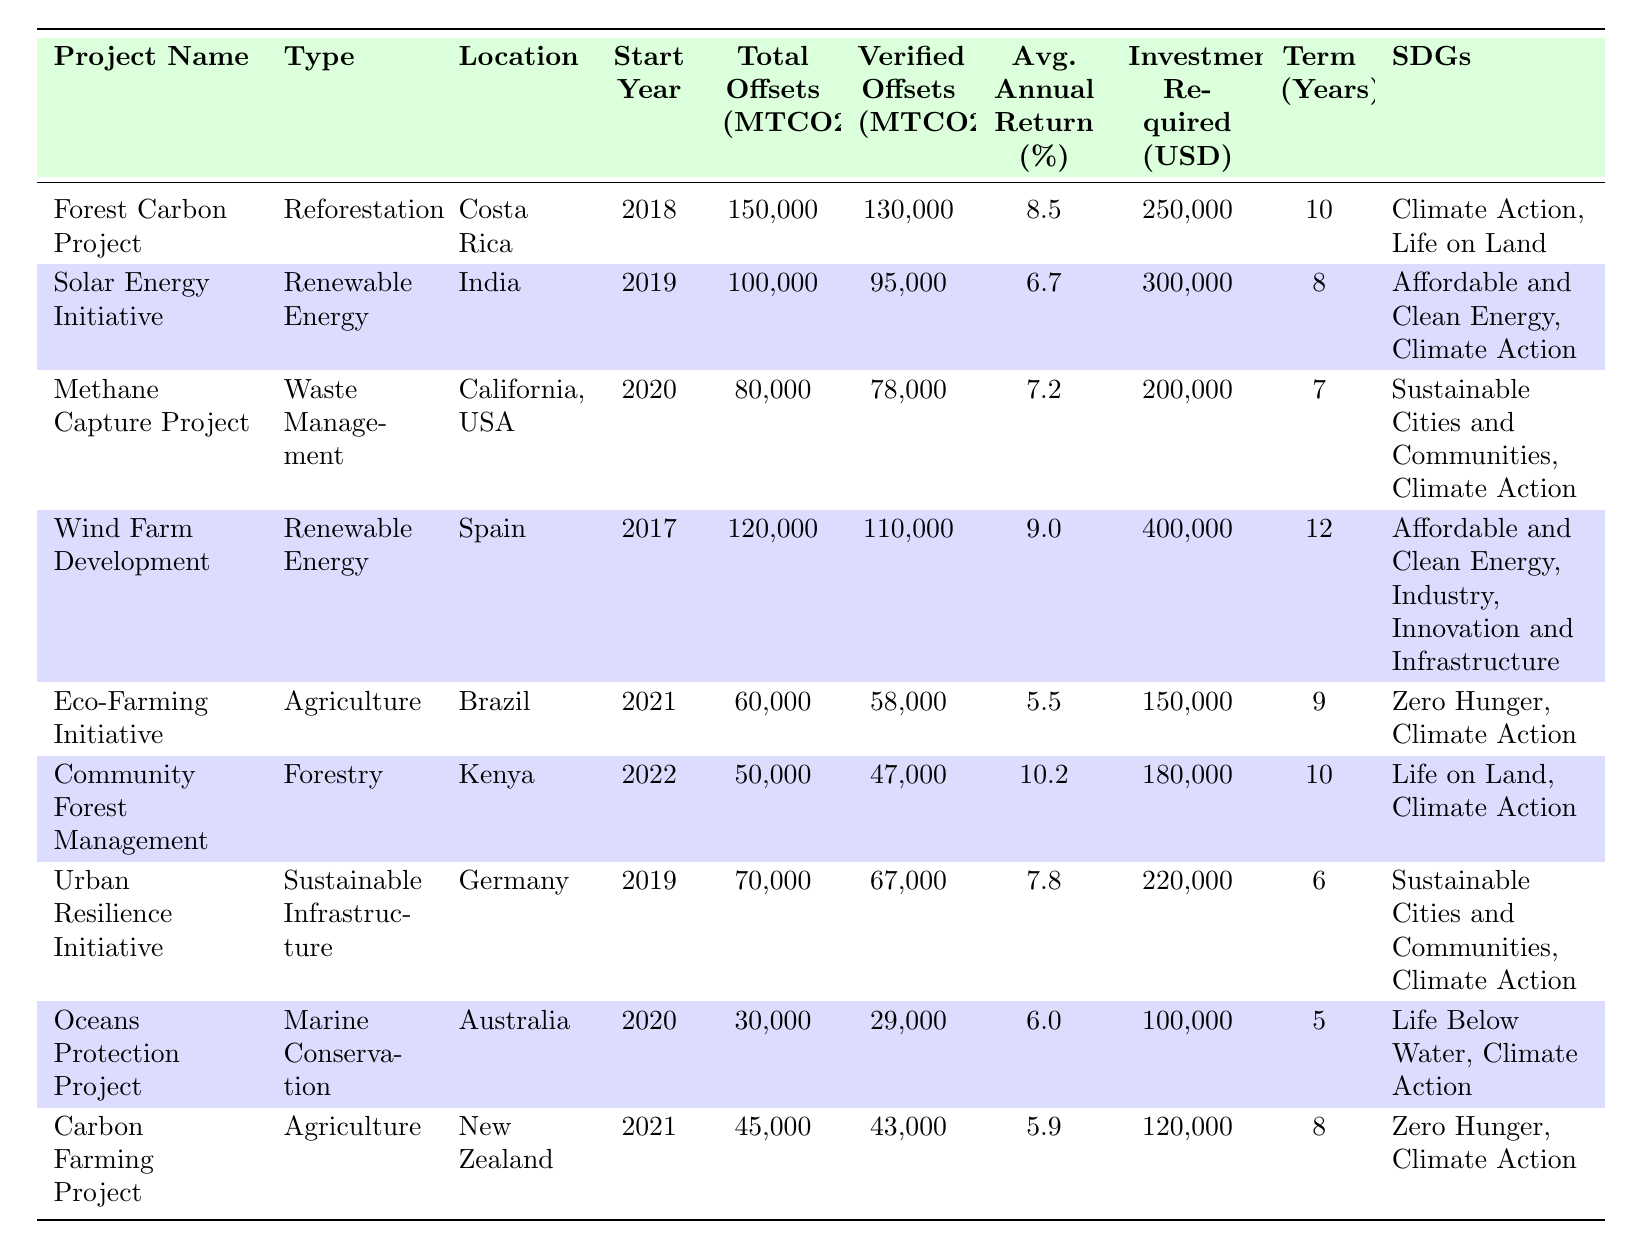What project has the highest average annual return percentage? The table shows the average annual return percentage for each project. The highest value is 10.2%, associated with the Community Forest Management project in Kenya.
Answer: 10.2% How many projects are categorized as Renewable Energy? The table lists the projects under the "Type" column. There are two projects under Renewable Energy: the Solar Energy Initiative (India) and Wind Farm Development (Spain).
Answer: 2 What is the total carbon offset (MTCO2e) for all projects listed? To find the total carbon offset, add the total offsets for each project: 150,000 + 100,000 + 80,000 + 120,000 + 60,000 + 50,000 + 70,000 + 30,000 + 45,000 = 705,000.
Answer: 705,000 MTCO2e Which project has the lowest investment required? By inspecting the "Investment Required" column, the project with the lowest investment of USD 100,000 is the Oceans Protection Project in Australia.
Answer: 100,000 USD Is there a project that meets the Sustainable Development Goal of "Zero Hunger"? The Eco-Farming Initiative (Brazil) and Carbon Farming Project (New Zealand) both aim to achieve the Sustainable Development Goal of "Zero Hunger".
Answer: Yes What is the average investment required for projects in Africa? The projects in Africa include the Community Forest Management (Kenya). The investment required is USD 180,000. Since there's only one project, the average is also 180,000.
Answer: 180,000 USD Calculate the average return percentage for all projects launched after 2020. The projects launched after 2020 are: Methane Capture Project (7.2%), Community Forest Management (10.2%), Eco-Farming Initiative (5.5%), and Carbon Farming Project (5.9%). The average is calculated as (7.2 + 10.2 + 5.5 + 5.9) / 4 = 7.0%.
Answer: 7.0% How many projects have a term longer than 8 years? By examining the "Term" column, the projects with investments terms longer than 8 years are: Forest Carbon Project (10 years), Wind Farm Development (12 years), and Community Forest Management (10 years). Thus, there are three such projects.
Answer: 3 What is the difference in total offsets between the Forest Carbon Project and the Eco-Farming Initiative? The Forest Carbon Project has 150,000 total offsets and the Eco-Farming Initiative has 60,000. The difference is 150,000 - 60,000 = 90,000 MTCO2e.
Answer: 90,000 MTCO2e Which project type contributes the most to carbon offsets? By comparing total carbon offsets, the Forest Carbon Project (150,000 MTCO2e) contributes the most as it's a Reforestation type.
Answer: Reforestation 